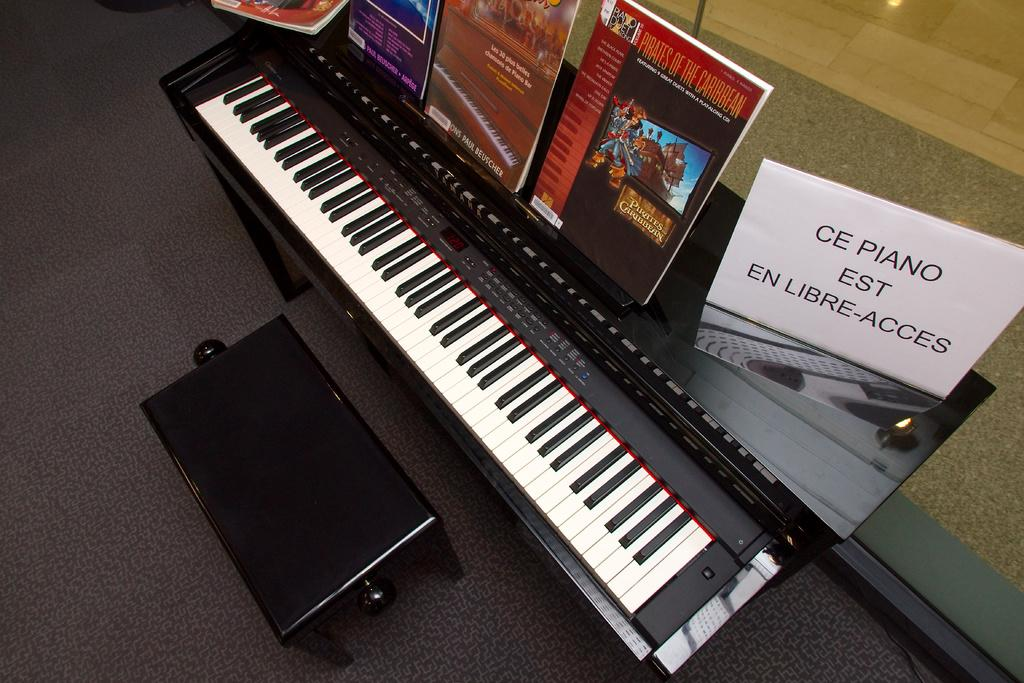What is the main object in the image? There is a piano in the image. What else can be seen on the piano? There are books on the piano. What type of plant is growing on the piano in the image? There is no plant growing on the piano in the image. Can you hear a horn playing in the background of the image? There is no sound or horn present in the image, as it is a still photograph. 